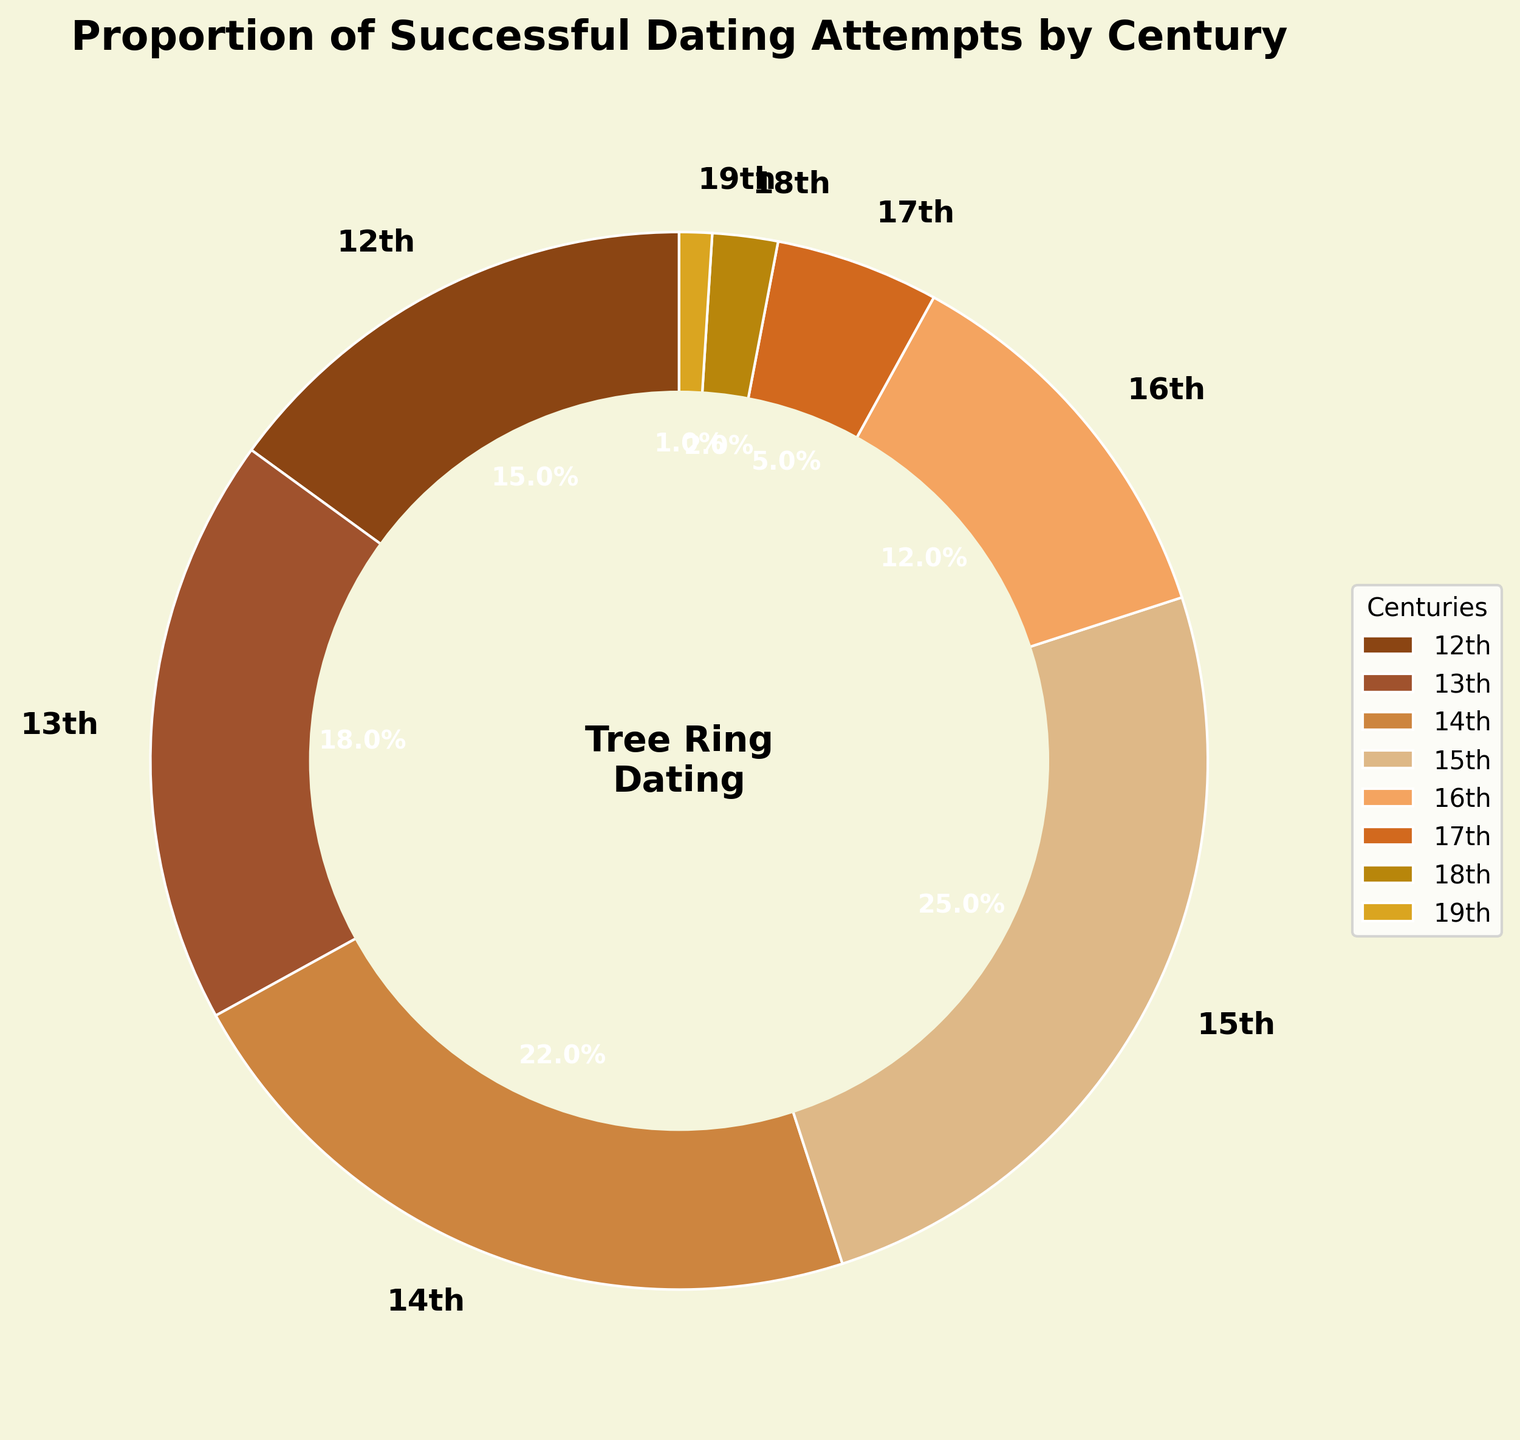What century saw the highest proportion of successful dating attempts? Look at the largest slice of the pie chart, which represents the century with the highest proportion. The 15th century has a larger slice compared to the others.
Answer: 15th How does the sum of the proportions for the 12th and 13th centuries compare to the 15th century? Add the proportions of the 12th and 13th centuries: 0.15 + 0.18 = 0.33. Compare this sum to the 15th century's proportion of 0.25.
Answer: 12th + 13th > 15th Which century has the smallest proportion of successful dating attempts and what is that proportion? Look for the smallest slice in the pie chart, which represents the century with the smallest proportion. The 19th century has the smallest slice.
Answer: 19th, 0.01 Are there any centuries with proportions of successful dating attempts greater than 20%? Identify the slices with proportions greater than 20%, which are above the threshold. The 14th and 15th centuries are above this threshold.
Answer: 14th, 15th What is the visual difference between the slices representing the 17th and 18th centuries? Visually compare the sizes of the slices for these two centuries in the pie chart. The 17th century slice is larger than the 18th century slice.
Answer: 17th > 18th How much larger is the proportion of the 12th century compared to the 16th century? Subtract the 16th century proportion from the 12th century proportion: 0.15 - 0.12 = 0.03.
Answer: 0.03 Which centuries together make up less than 10% of successful dating attempts? Sum the proportions of the 17th, 18th, and 19th centuries (0.05 + 0.02 + 0.01) to see if they are less than 10%. The total is 0.08, so together they make up less than 10%.
Answer: 17th, 18th, 19th How many centuries have a proportion of successful dating attempts within 1% of the 16th century? Identify the proportions close to 0.12 (16th century's proportion). Both the 17th century (0.05) and the 18th century (0.02) are more than 1% away from 0.12. Hence, none are within 1%.
Answer: 0 